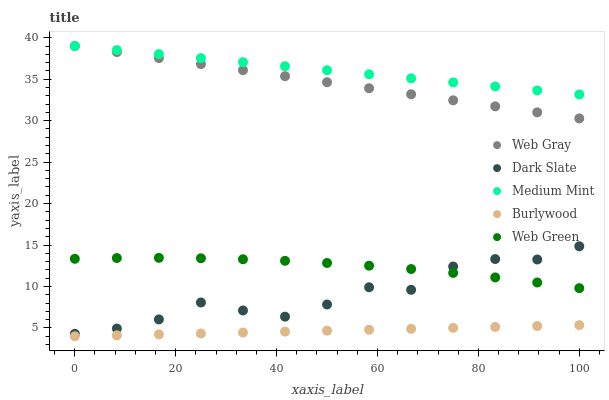Does Burlywood have the minimum area under the curve?
Answer yes or no. Yes. Does Medium Mint have the maximum area under the curve?
Answer yes or no. Yes. Does Dark Slate have the minimum area under the curve?
Answer yes or no. No. Does Dark Slate have the maximum area under the curve?
Answer yes or no. No. Is Burlywood the smoothest?
Answer yes or no. Yes. Is Dark Slate the roughest?
Answer yes or no. Yes. Is Web Gray the smoothest?
Answer yes or no. No. Is Web Gray the roughest?
Answer yes or no. No. Does Burlywood have the lowest value?
Answer yes or no. Yes. Does Dark Slate have the lowest value?
Answer yes or no. No. Does Web Gray have the highest value?
Answer yes or no. Yes. Does Dark Slate have the highest value?
Answer yes or no. No. Is Burlywood less than Web Green?
Answer yes or no. Yes. Is Medium Mint greater than Burlywood?
Answer yes or no. Yes. Does Web Green intersect Dark Slate?
Answer yes or no. Yes. Is Web Green less than Dark Slate?
Answer yes or no. No. Is Web Green greater than Dark Slate?
Answer yes or no. No. Does Burlywood intersect Web Green?
Answer yes or no. No. 